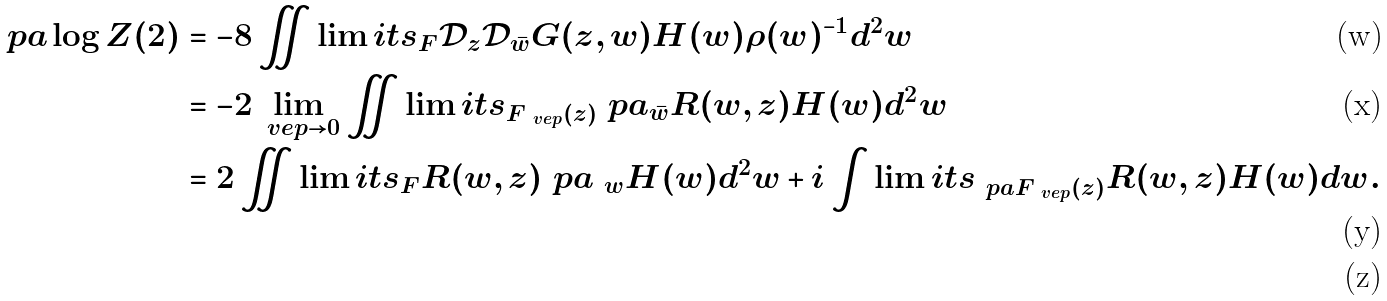Convert formula to latex. <formula><loc_0><loc_0><loc_500><loc_500>\ p a \log Z ( 2 ) & = - 8 \iint \lim i t s _ { F } \mathcal { D } _ { z } \mathcal { D } _ { \bar { w } } G ( z , w ) H ( w ) \rho ( w ) ^ { - 1 } d ^ { 2 } w \\ & = - 2 \lim _ { \ v e p \rightarrow 0 } \iint \lim i t s _ { F _ { \ v e p } ( z ) } \ p a _ { \bar { w } } R ( w , z ) H ( w ) d ^ { 2 } w \\ & = 2 \iint \lim i t s _ { F } R ( w , z ) \ p a _ { \ w } H ( w ) d ^ { 2 } w + i \int \lim i t s _ { \ p a F _ { \ v e p } ( z ) } R ( w , z ) H ( w ) d w . \\</formula> 